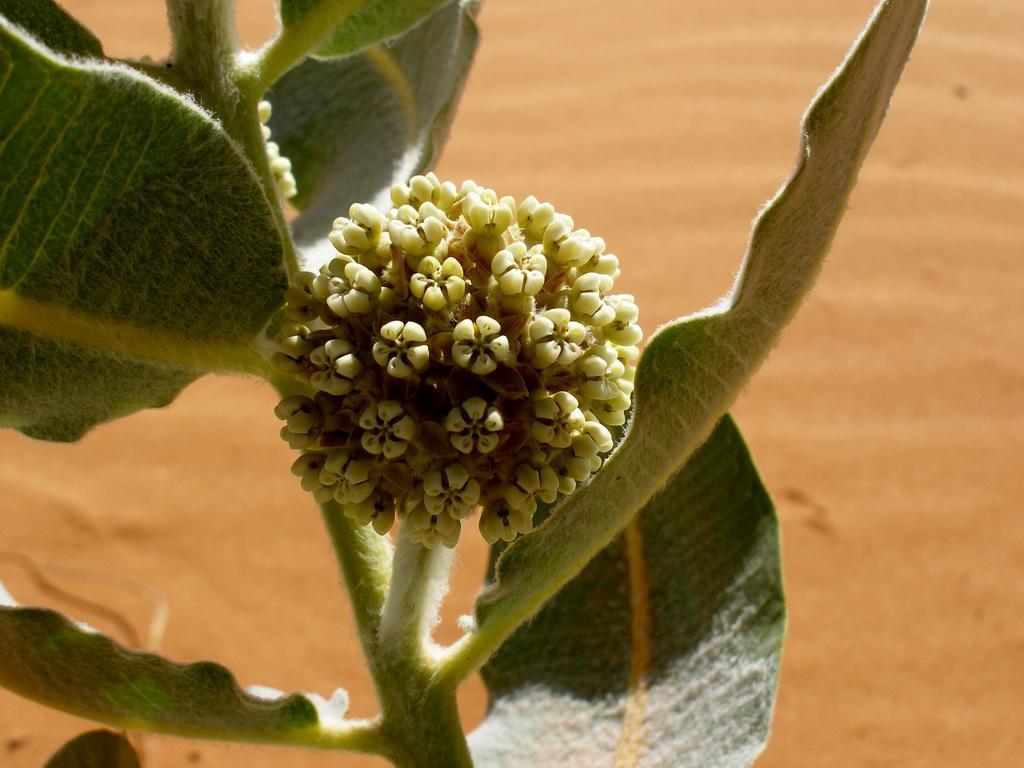Please provide a concise description of this image. In this image there is a plant with the flower, and there is a brown background. 